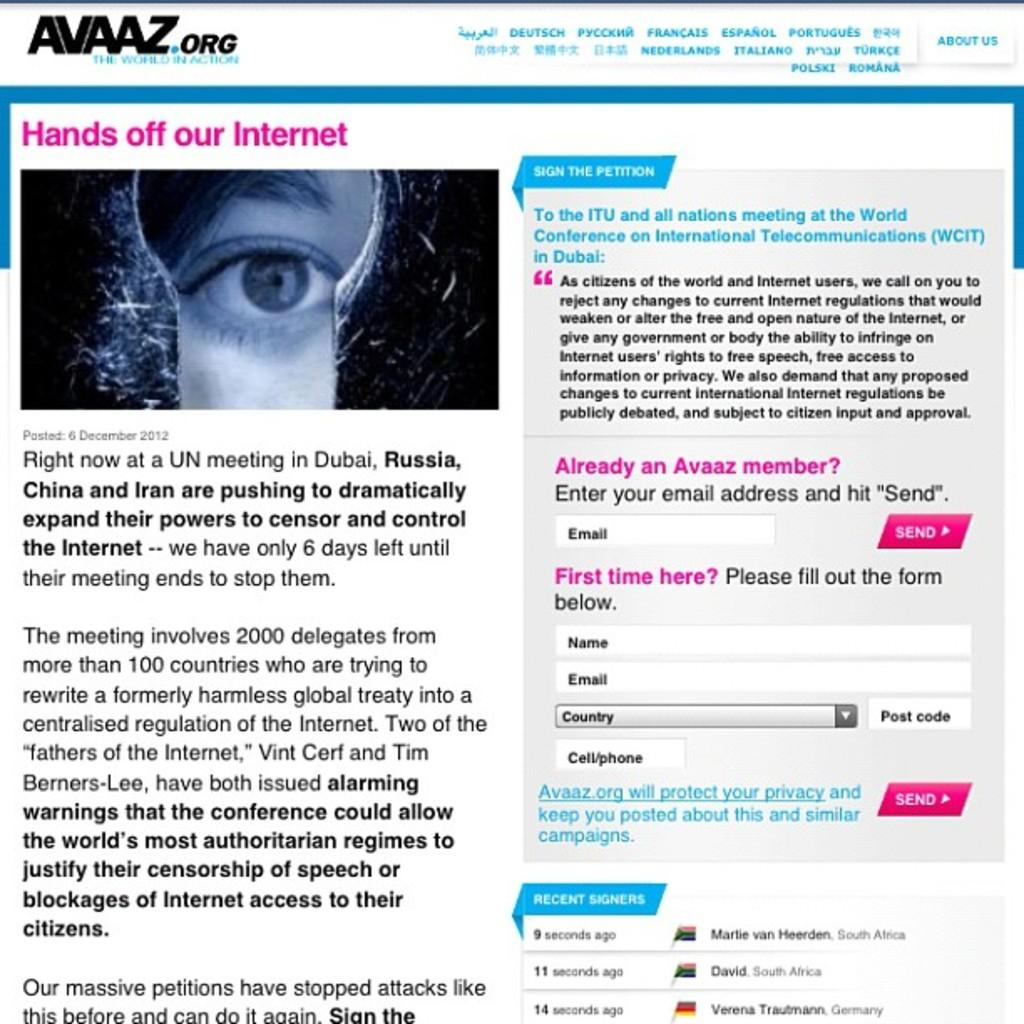What can be found on the left side of the image? There is text on the left side of the image. What can be found on the right side of the image? There is text on the right side of the image. Can you describe any other visual elements in the image? Yes, there is an eye of a person on the top left side of the image. What advice is the representative giving in the image? There is no representative or advice present in the image; it only contains text and an eye. 